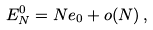Convert formula to latex. <formula><loc_0><loc_0><loc_500><loc_500>E ^ { 0 } _ { N } = N e _ { 0 } + o ( N ) \, ,</formula> 